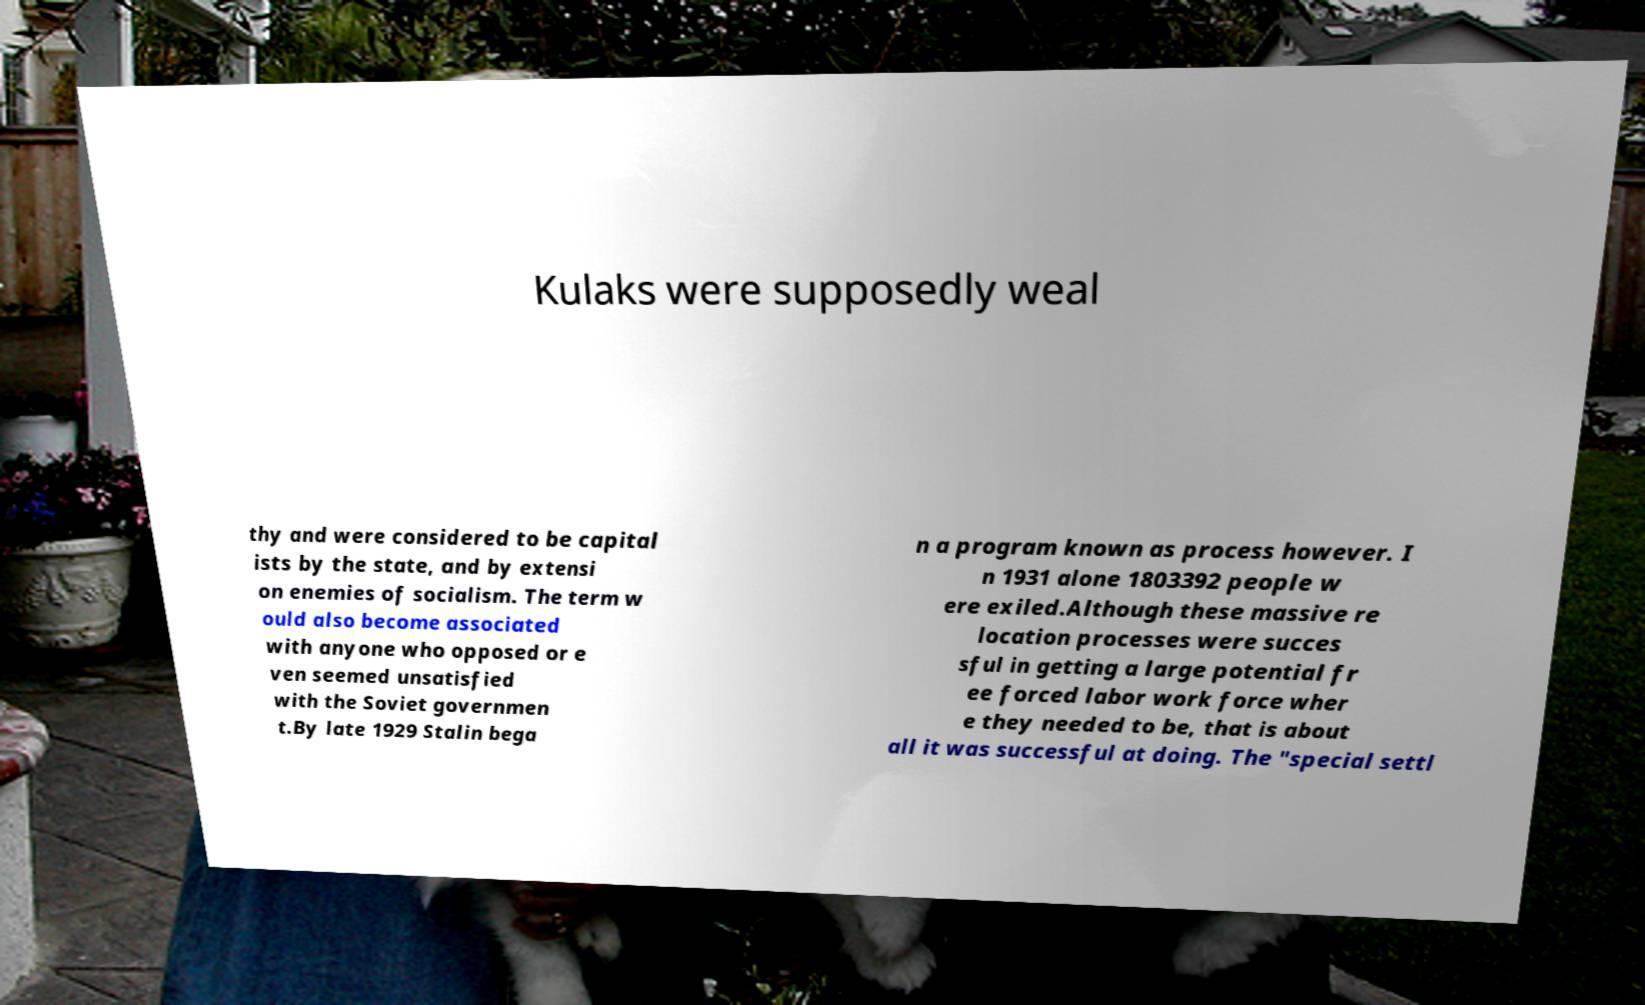There's text embedded in this image that I need extracted. Can you transcribe it verbatim? Kulaks were supposedly weal thy and were considered to be capital ists by the state, and by extensi on enemies of socialism. The term w ould also become associated with anyone who opposed or e ven seemed unsatisfied with the Soviet governmen t.By late 1929 Stalin bega n a program known as process however. I n 1931 alone 1803392 people w ere exiled.Although these massive re location processes were succes sful in getting a large potential fr ee forced labor work force wher e they needed to be, that is about all it was successful at doing. The "special settl 